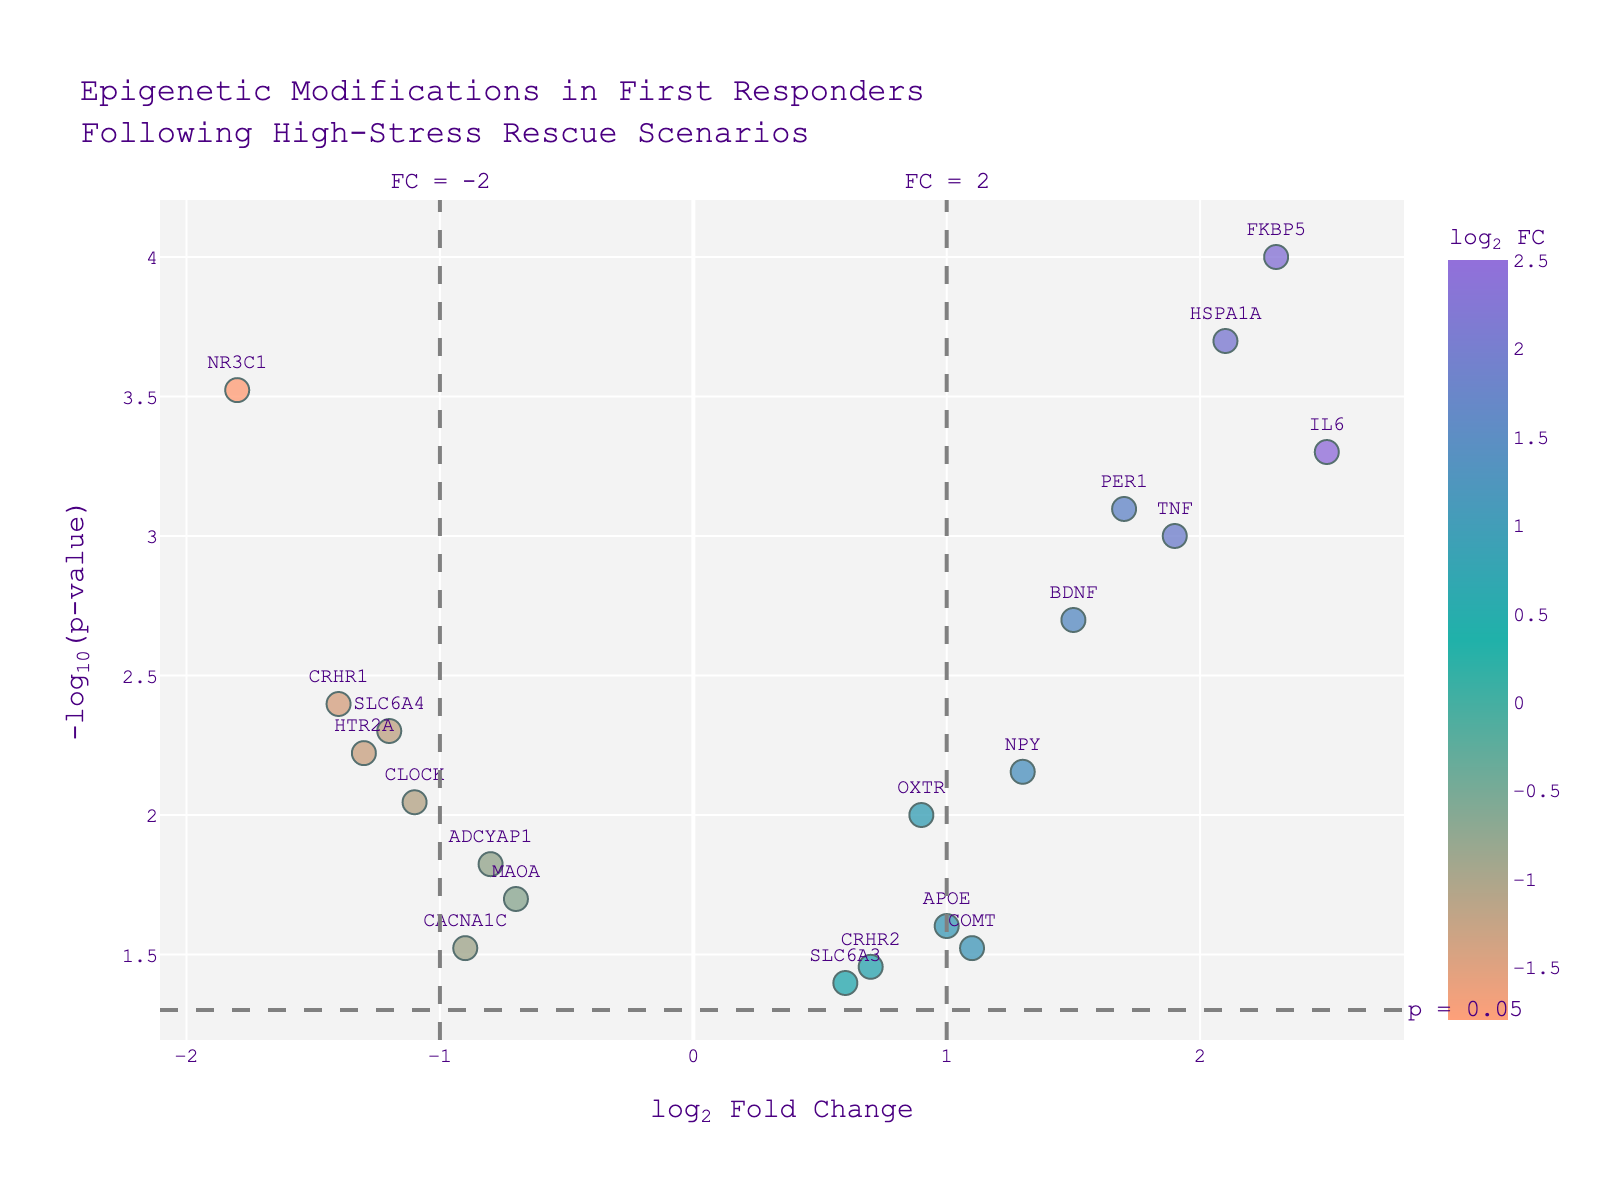what does the title of the figure indicate? The title indicates that the figure represents epigenetic modifications observed in first responders following high-stress rescue scenarios. This sets the context for the data shown in the plot.
Answer: Epigenetic modifications in first responders following high-stress rescue scenarios What do the x-axis and y-axis represent? The x-axis represents the log2 fold change in gene expression, indicating the change in expression levels between two conditions. The y-axis represents the -log10 of the p-value, indicating the statistical significance of the changes.
Answer: log2 fold change and -log10(p-value) How many genes have a log2 fold change greater than 1? Look for data points to the right of the vertical line at log2 fold change = 1. Count the number of these data points. Genes that meet this criteria include FKBP5, IL6, TNF, PER1, HSPA1A, and others.
Answer: 8 What is the gene with the most significant p-value? Find the data point with the highest -log10(p-value). This corresponds to the smallest p-value. FKBP5 is the gene with the highest point.
Answer: FKBP5 Which genes have a log2 fold change less than -1 and are statistically significant? Look for data points left of the vertical line at log2 fold change = -1 and above the horizontal line at -log10(p-value) = 1.3.
Answer: NR3C1, CRHR1, HTR2A How many data points are above the p-value significance threshold (p<0.05)? Count all data points above the horizontal line at -log10(p-value) = 1.3.
Answer: 9 What is the range of log2 fold changes represented in the plot? Identify the smallest and largest log2 fold change values on the x-axis. The minimum value is approximately -1.8 (NR3C1) and the maximum value is approximately 2.5 (IL6).
Answer: -1.8 to 2.5 Which gene has the highest log2 fold change, and how significant is it statistically? Identify the gene with the highest log2 fold change, which is IL6. Then look at its corresponding -log10(p-value) to assess its significance. IL6 has a -log10(p-value) around 3.3.
Answer: IL6, highly significant How are the significantly upregulated and downregulated genes visually differentiated? Upregulated genes are represented by data points with positive log2 fold changes (right of the origin), while downregulated genes have negative log2 fold changes (left of the origin). The vertical dashed lines indicate thresholds for significant upregulation and downregulation.
Answer: by their position relative to the y-axis How many genes are shown in the plot? Count the total number of data points in the plot. Each data point represents one gene.
Answer: 20 